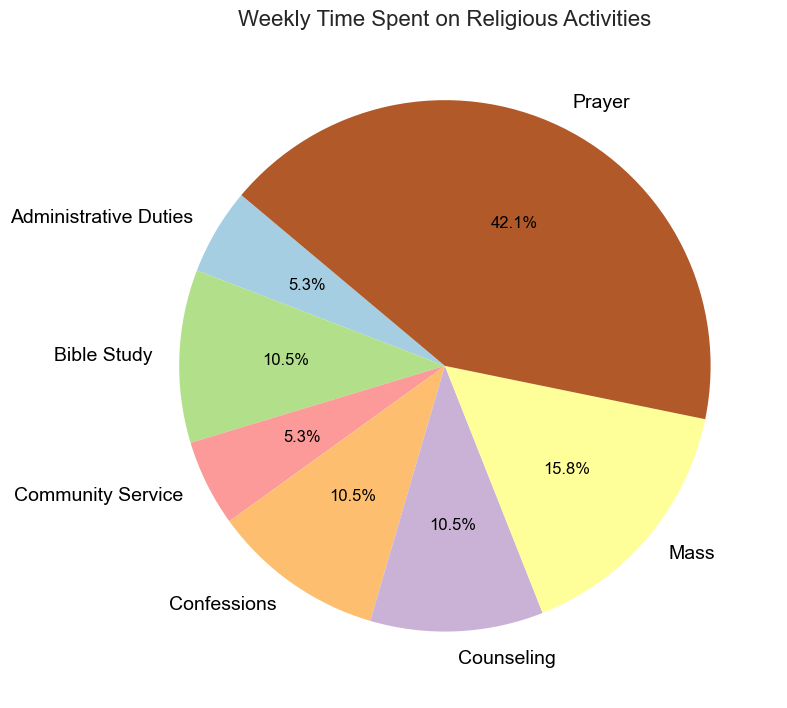Which activity takes the most time in a week? Look at the pie chart and find the activity with the largest slice. In this case, it's "Prayer".
Answer: Prayer How many hours are spent on Confessions and Counseling combined? Add the two segments for "Confessions" and "Counseling". 2 hours (Confessions) + 2 hours (Counseling) = 4 hours.
Answer: 4 hours Which activity takes more time, Mass or Bible Study? Compare the slices labeled "Mass" and "Bible Study". The "Mass" slice is larger.
Answer: Mass What percentage of the week is spent on Bible Study? Look for the percentage label on the "Bible Study" slice of the pie chart. It's 10%.
Answer: 10% Are more hours spent on Community Service or Administrative Duties? Compare the segments for "Community Service" and "Administrative Duties". Both have the same size slice, each representing 1 hour.
Answer: They are equal What is the combined percentage of time spent on Mass and Prayer? Add the percentages from the "Mass" and "Prayer" slices. Mass is 15.0% and Prayer is 40.0%. 15.0% + 40.0% = 55.0%
Answer: 55.0% Which activity uses less than 5% of the total weekly time? Look at the pie chart slices to identify which one shows less than 5%. "Community Service" and "Administrative Duties" each represent less than 5%.
Answer: Community Service and Administrative Duties How much more time is spent on Prayer compared to Mass? Subtract the hours for "Mass" from the hours for "Prayer". 8 hours (Prayer) - 3 hours (Mass) = 5 hours.
Answer: 5 hours What is the combined percentage of time spent on Confessions, Bible Study, and Counseling? Add the percentages for "Confessions", "Bible Study", and "Counseling". Confessions (10.0%) + Bible Study (10.0%) + Counseling (10.0%) = 30.0%.
Answer: 30.0% Which activity takes up exactly 10% of the week? Find the slices labeled with exactly 10.0%. Both "Confessions" and "Counseling" take up 10.0% each.
Answer: Confessions and Counseling 